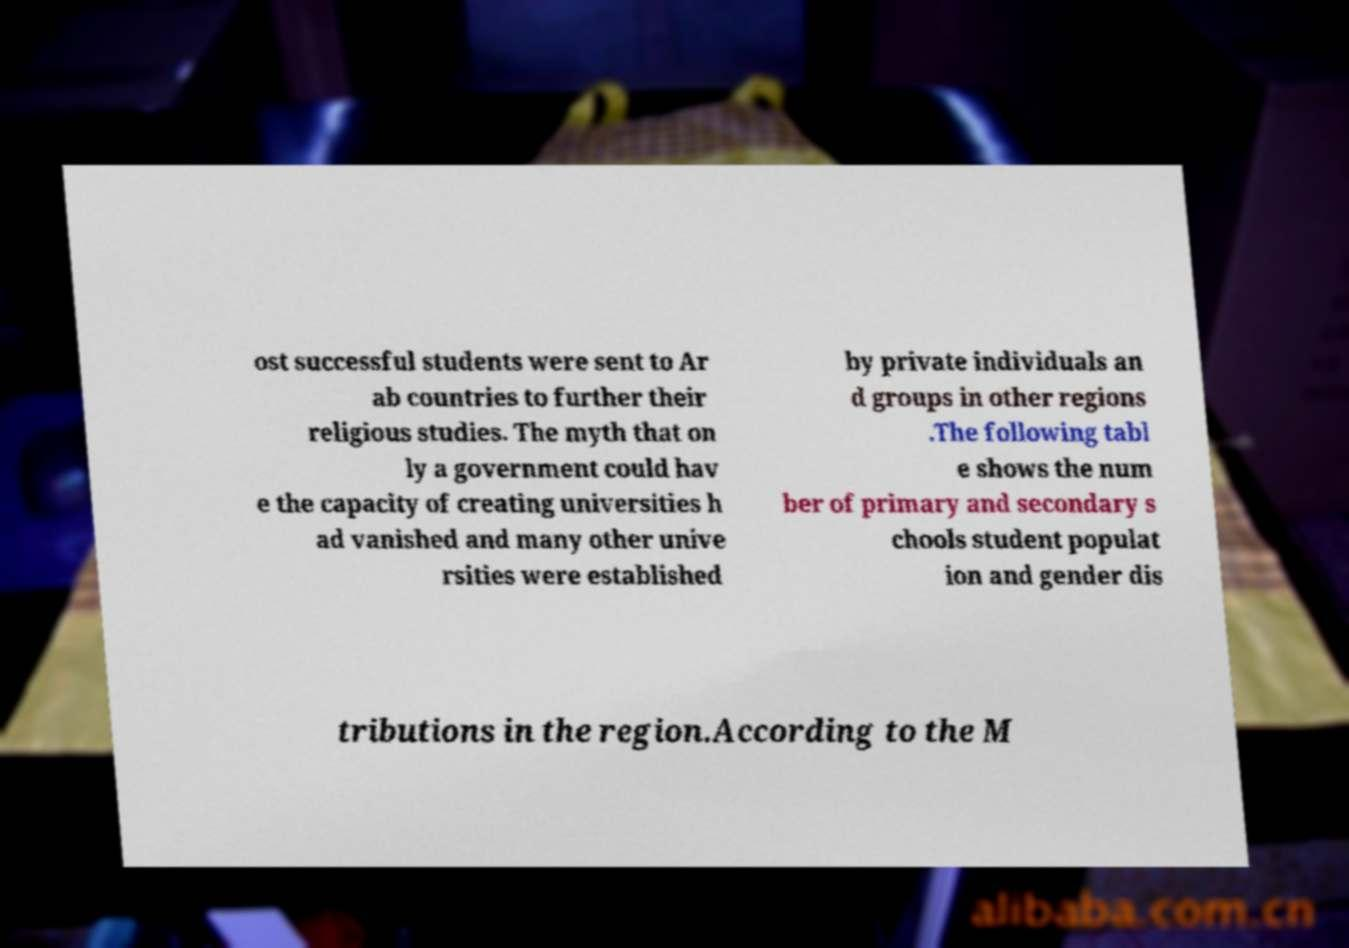I need the written content from this picture converted into text. Can you do that? ost successful students were sent to Ar ab countries to further their religious studies. The myth that on ly a government could hav e the capacity of creating universities h ad vanished and many other unive rsities were established by private individuals an d groups in other regions .The following tabl e shows the num ber of primary and secondary s chools student populat ion and gender dis tributions in the region.According to the M 